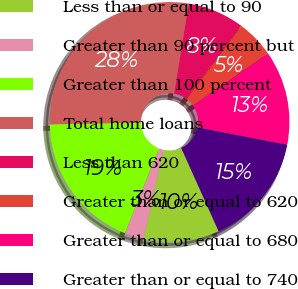<chart> <loc_0><loc_0><loc_500><loc_500><pie_chart><fcel>Less than or equal to 90<fcel>Greater than 90 percent but<fcel>Greater than 100 percent<fcel>Total home loans<fcel>Less than 620<fcel>Greater than or equal to 620<fcel>Greater than or equal to 680<fcel>Greater than or equal to 740<nl><fcel>10.18%<fcel>2.59%<fcel>18.62%<fcel>27.89%<fcel>7.65%<fcel>5.12%<fcel>12.71%<fcel>15.24%<nl></chart> 